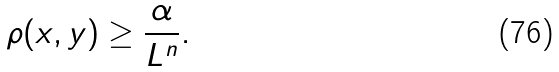Convert formula to latex. <formula><loc_0><loc_0><loc_500><loc_500>\rho ( x , y ) \geq \frac { \alpha } { L ^ { n } } .</formula> 